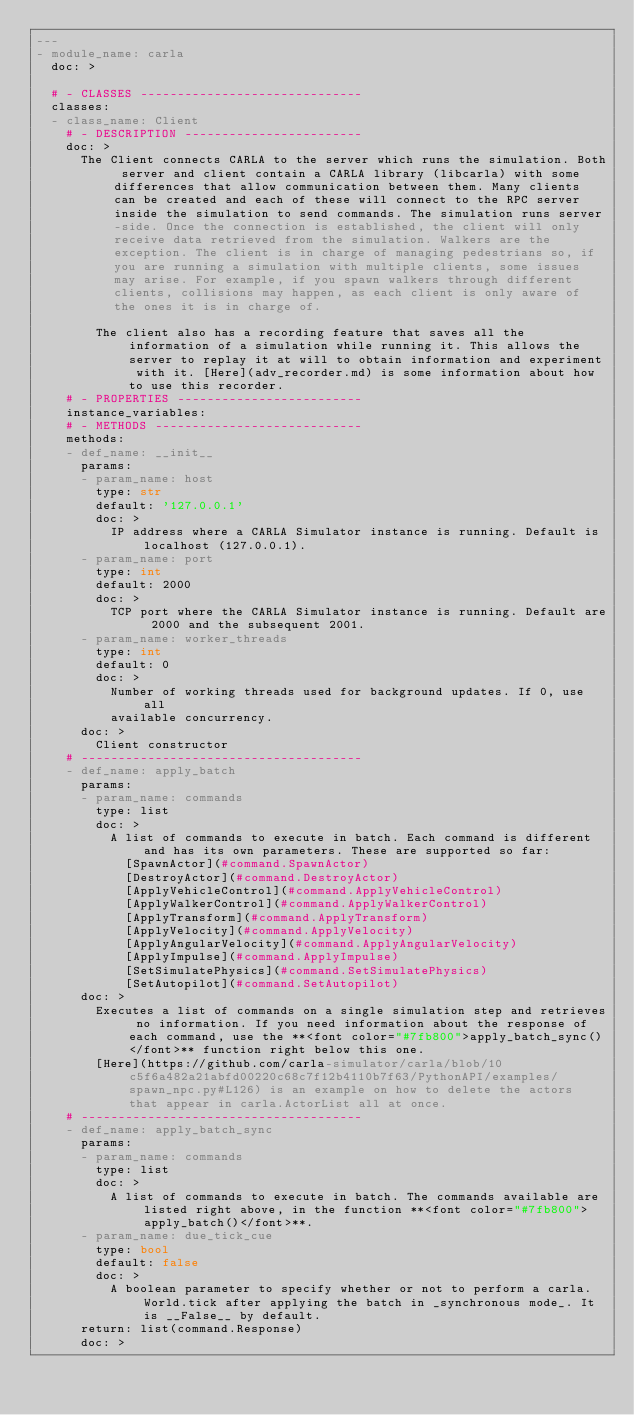<code> <loc_0><loc_0><loc_500><loc_500><_YAML_>---
- module_name: carla
  doc: >

  # - CLASSES ------------------------------
  classes:
  - class_name: Client
    # - DESCRIPTION ------------------------
    doc: >
      The Client connects CARLA to the server which runs the simulation. Both server and client contain a CARLA library (libcarla) with some differences that allow communication between them. Many clients can be created and each of these will connect to the RPC server inside the simulation to send commands. The simulation runs server-side. Once the connection is established, the client will only receive data retrieved from the simulation. Walkers are the exception. The client is in charge of managing pedestrians so, if you are running a simulation with multiple clients, some issues may arise. For example, if you spawn walkers through different clients, collisions may happen, as each client is only aware of the ones it is in charge of.

        The client also has a recording feature that saves all the information of a simulation while running it. This allows the server to replay it at will to obtain information and experiment with it. [Here](adv_recorder.md) is some information about how to use this recorder.
    # - PROPERTIES -------------------------
    instance_variables:
    # - METHODS ----------------------------
    methods:
    - def_name: __init__
      params:
      - param_name: host
        type: str
        default: '127.0.0.1'
        doc: >
          IP address where a CARLA Simulator instance is running. Default is localhost (127.0.0.1).
      - param_name: port
        type: int
        default: 2000
        doc: >
          TCP port where the CARLA Simulator instance is running. Default are 2000 and the subsequent 2001.
      - param_name: worker_threads
        type: int
        default: 0
        doc: >
          Number of working threads used for background updates. If 0, use all
          available concurrency.
      doc: >
        Client constructor
    # --------------------------------------
    - def_name: apply_batch
      params:
      - param_name: commands
        type: list
        doc: >
          A list of commands to execute in batch. Each command is different and has its own parameters. These are supported so far:
            [SpawnActor](#command.SpawnActor)
            [DestroyActor](#command.DestroyActor)
            [ApplyVehicleControl](#command.ApplyVehicleControl)
            [ApplyWalkerControl](#command.ApplyWalkerControl)
            [ApplyTransform](#command.ApplyTransform)
            [ApplyVelocity](#command.ApplyVelocity)
            [ApplyAngularVelocity](#command.ApplyAngularVelocity)
            [ApplyImpulse](#command.ApplyImpulse)
            [SetSimulatePhysics](#command.SetSimulatePhysics)
            [SetAutopilot](#command.SetAutopilot)
      doc: >
        Executes a list of commands on a single simulation step and retrieves no information. If you need information about the response of each command, use the **<font color="#7fb800">apply_batch_sync()</font>** function right below this one.
        [Here](https://github.com/carla-simulator/carla/blob/10c5f6a482a21abfd00220c68c7f12b4110b7f63/PythonAPI/examples/spawn_npc.py#L126) is an example on how to delete the actors that appear in carla.ActorList all at once.
    # --------------------------------------
    - def_name: apply_batch_sync
      params:
      - param_name: commands
        type: list
        doc: >
          A list of commands to execute in batch. The commands available are listed right above, in the function **<font color="#7fb800">apply_batch()</font>**.
      - param_name: due_tick_cue
        type: bool
        default: false
        doc: >
          A boolean parameter to specify whether or not to perform a carla.World.tick after applying the batch in _synchronous mode_. It is __False__ by default. 
      return: list(command.Response)
      doc: ></code> 